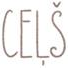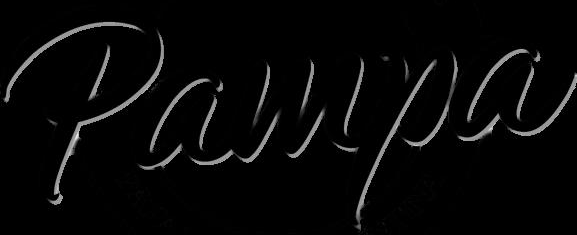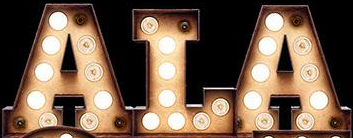Read the text content from these images in order, separated by a semicolon. CEḶŠ; Pampa; ALA 